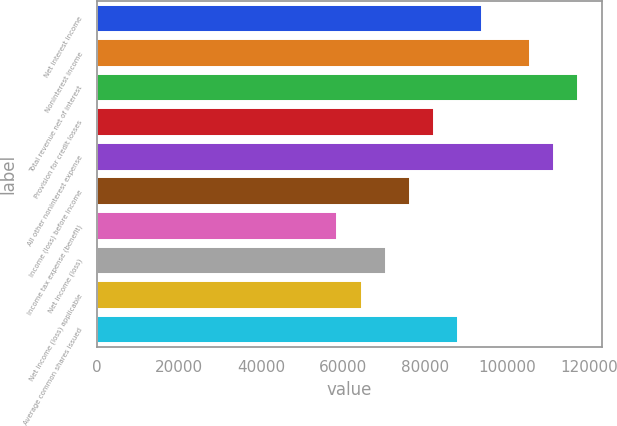<chart> <loc_0><loc_0><loc_500><loc_500><bar_chart><fcel>Net interest income<fcel>Noninterest income<fcel>Total revenue net of interest<fcel>Provision for credit losses<fcel>All other noninterest expense<fcel>Income (loss) before income<fcel>Income tax expense (benefit)<fcel>Net income (loss)<fcel>Net income (loss) applicable<fcel>Average common shares issued<nl><fcel>93728<fcel>105444<fcel>117160<fcel>82012<fcel>111302<fcel>76154<fcel>58580<fcel>70296<fcel>64438<fcel>87870<nl></chart> 